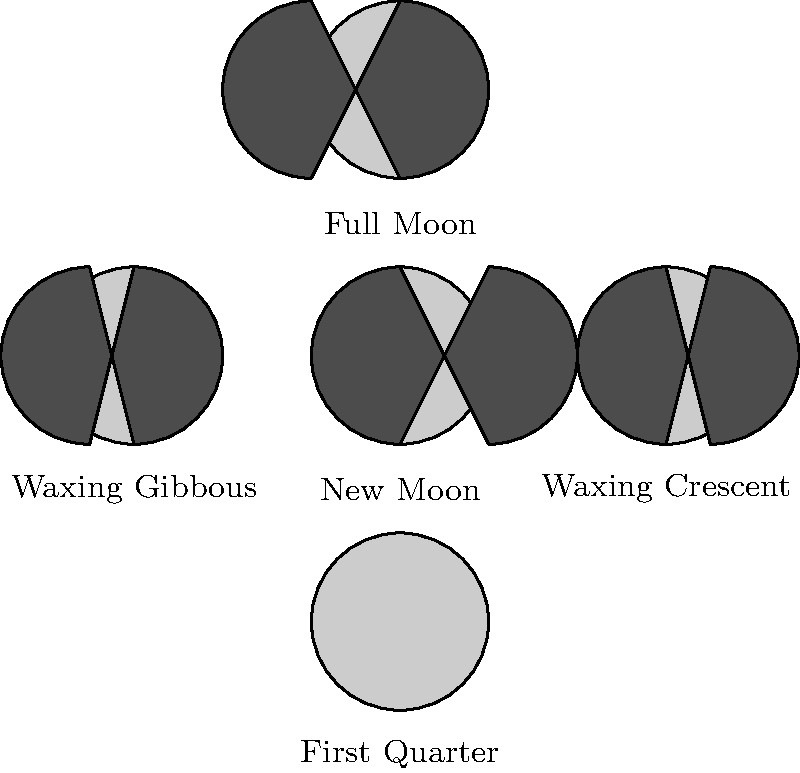In the circular diagram showing different lunar appearances, which phase of the Moon is missing? And honestly, isn't it just like Bollywood to leave out crucial details in their cosmic dance numbers? Let's break this down step-by-step, just like we would analyze a Bollywood plot twist:

1. The diagram shows 5 phases of the Moon in a circular arrangement.

2. The phases shown are:
   - New Moon (completely dark)
   - Waxing Crescent (small illuminated crescent on the right)
   - First Quarter (right half illuminated)
   - Waxing Gibbous (mostly illuminated with a dark portion on the left)
   - Full Moon (completely illuminated)

3. The complete cycle of lunar phases includes 8 main stages:
   1. New Moon
   2. Waxing Crescent
   3. First Quarter
   4. Waxing Gibbous
   5. Full Moon
   6. Waning Gibbous
   7. Last Quarter
   8. Waning Crescent

4. Comparing the diagram to the complete cycle, we can see that the phases after the Full Moon are missing.

5. The missing phases are:
   - Waning Gibbous
   - Last Quarter
   - Waning Crescent

6. Among these, the most significant missing phase is the Last Quarter, as it's one of the four primary Moon phases (along with New Moon, First Quarter, and Full Moon).

So, just like how Bollywood often leaves out logical explanations in their scripts, this diagram is missing a crucial phase - the Last Quarter Moon.
Answer: Last Quarter Moon 